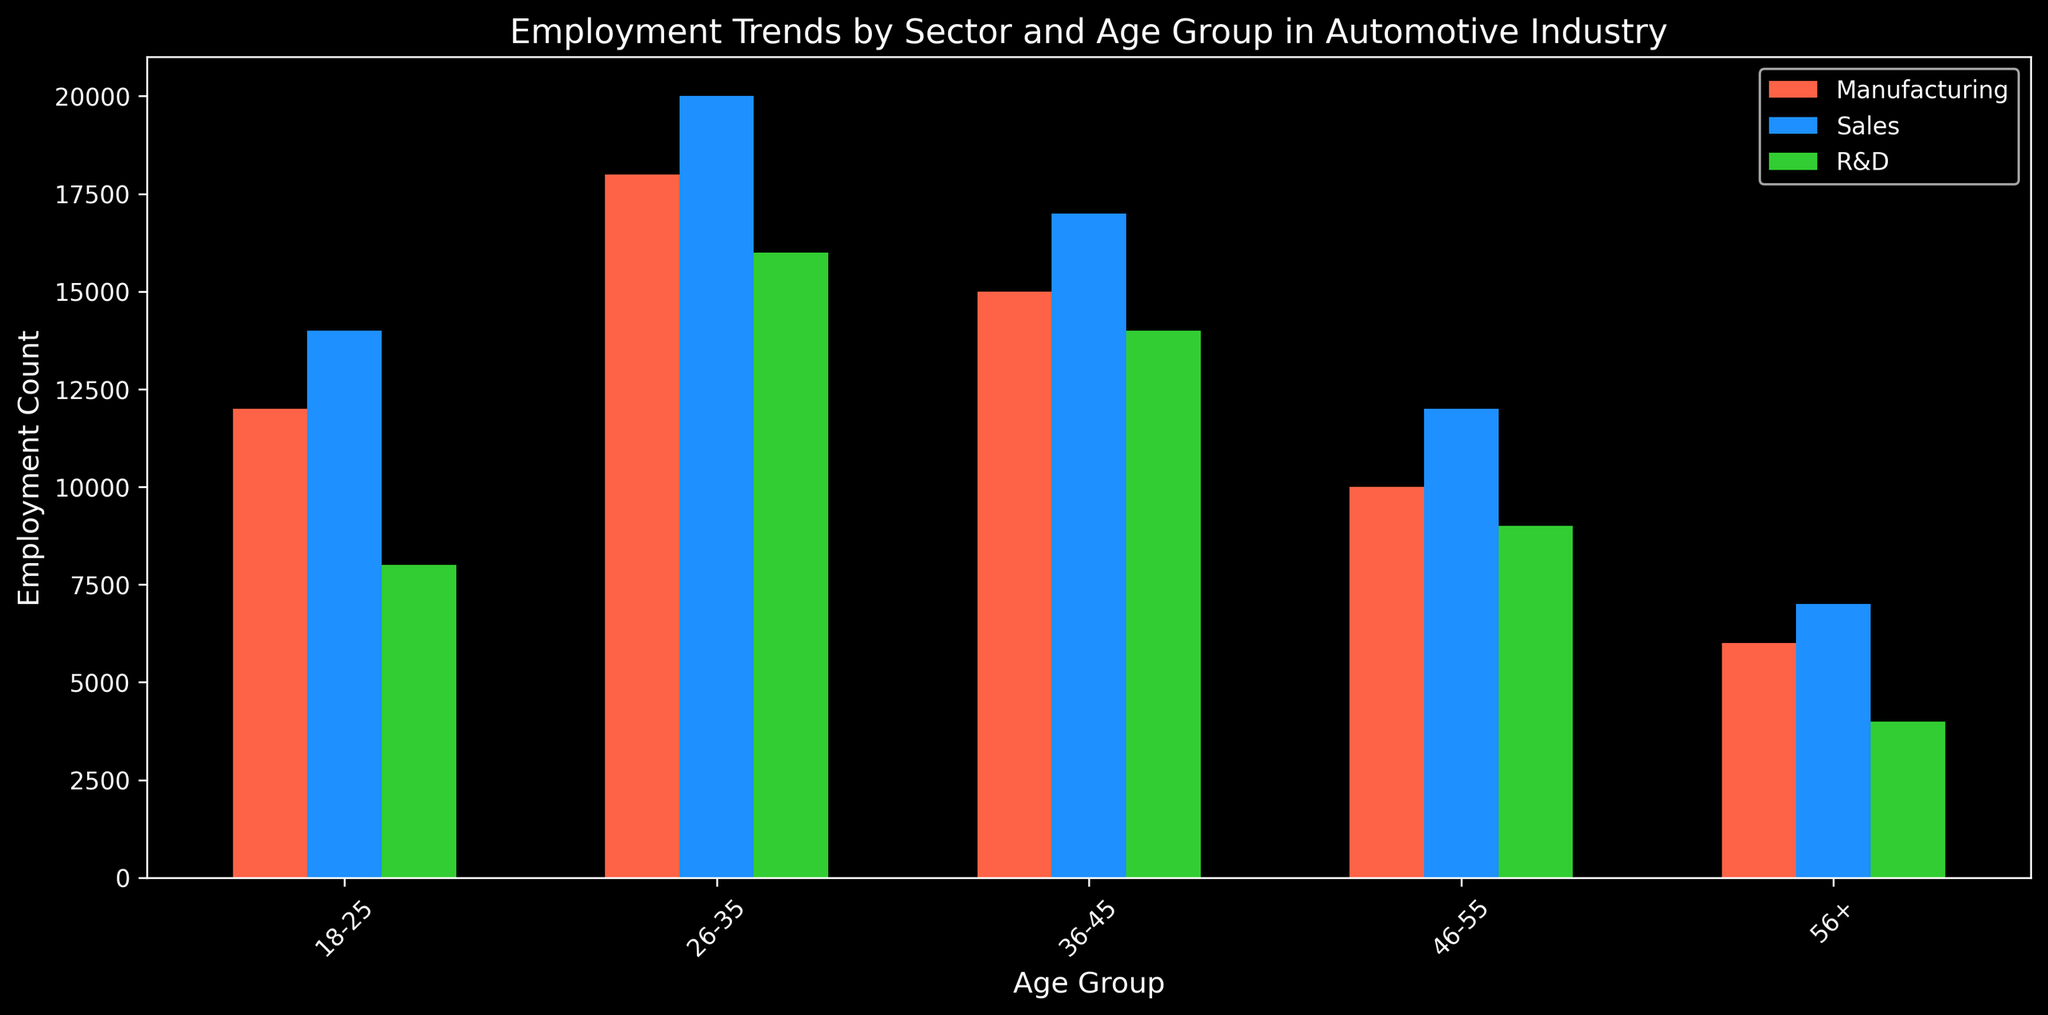Which sector has the highest employment count in the 26-35 age group? In the grouped bar plot, compare the bar heights for the 26-35 age group across the three sectors. The Sales sector's bar is the tallest.
Answer: Sales What is the total employment count in the 46-55 age group across all sectors? Sum the employment counts for Manufacturing (10,000), Sales (12,000), and R&D (9,000) in the 46-55 age group: 10,000 + 12,000 + 9,000 = 31,000.
Answer: 31,000 Which age group has the lowest employment count in R&D? In the grouped bar plot, look for the smallest bar within R&D across all age groups. The 56+ age group has the shortest bar.
Answer: 56+ Is the employment count for the 36-45 age group in Manufacturing greater than in R&D? Compare the heights of the bars for the 36-45 age group in Manufacturing and R&D. The Manufacturing bar is taller (15,000 vs. 14,000).
Answer: Yes What is the average employment count in the Manufacturing sector across all age groups? Find the employment counts in Manufacturing (12,000, 18,000, 15,000, 10,000, 6,000), sum them: 61,000, then divide by the number of age groups (5): 61,000 / 5 = 12,200.
Answer: 12,200 Which sector has the highest overall employment count when summing all age groups? Sum the employment counts for each sector:
Manufacturing: 12,000 + 18,000 + 15,000 + 10,000 + 6,000 = 61,000 
Sales: 14,000 + 20,000 + 17,000 + 12,000 + 7,000 = 70,000 
R&D: 8,000 + 16,000 + 14,000 + 9,000 + 4,000 = 51,000. 
Sales has the highest total.
Answer: Sales How does the employment count for the 18-25 age group in Sales compare to R&D? Compare the bar heights for the 18-25 age group in Sales and R&D. The Sales bar is taller (14,000 vs. 8,000).
Answer: Sales has more What is the difference in employment count between the 26-35 and 36-45 age groups in Sales? Subtract the employment count of the 36-45 age group from the 26-35 age group in Sales. 20,000 - 17,000 = 3,000.
Answer: 3,000 Is the employment count in the 56+ age group greater in Sales or Manufacturing? Compare the bar heights for the 56+ age group in Sales and Manufacturing. The Sales bar is taller (7,000 vs. 6,000).
Answer: Sales What is the rate of change in employment count from the 18-25 to the 26-35 age group in Manufacturing? Calculate the rate of change: (Employment in 26-35 - Employment in 18-25) / Employment in 18-25, which is (18,000 - 12,000) / 12,000 = 0.5.
Answer: 0.5 or 50% 